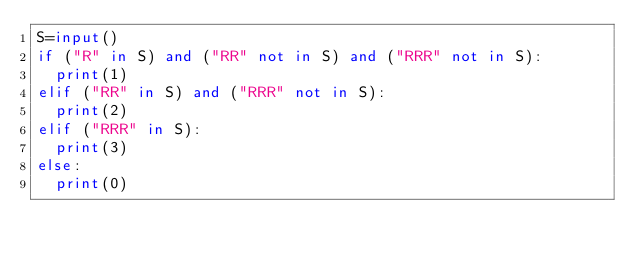Convert code to text. <code><loc_0><loc_0><loc_500><loc_500><_Python_>S=input()
if ("R" in S) and ("RR" not in S) and ("RRR" not in S):
  print(1)
elif ("RR" in S) and ("RRR" not in S):
  print(2)
elif ("RRR" in S):
  print(3)
else:
  print(0)</code> 